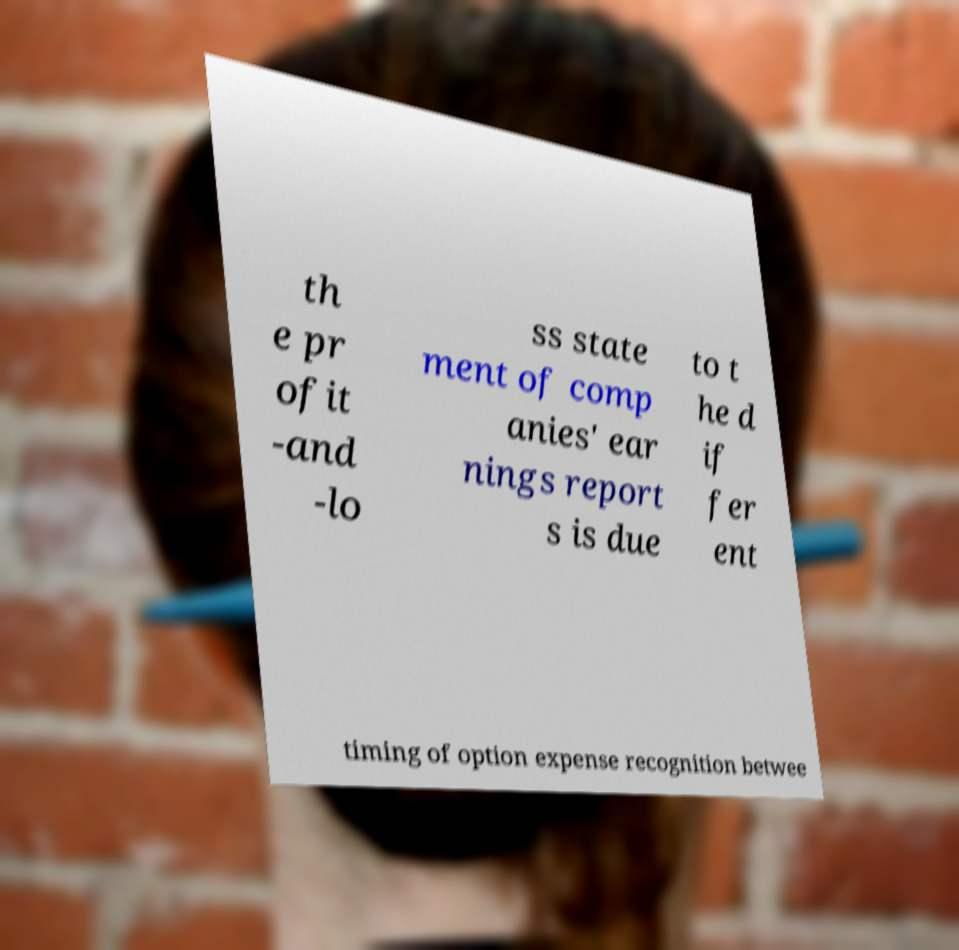Could you extract and type out the text from this image? th e pr ofit -and -lo ss state ment of comp anies' ear nings report s is due to t he d if fer ent timing of option expense recognition betwee 